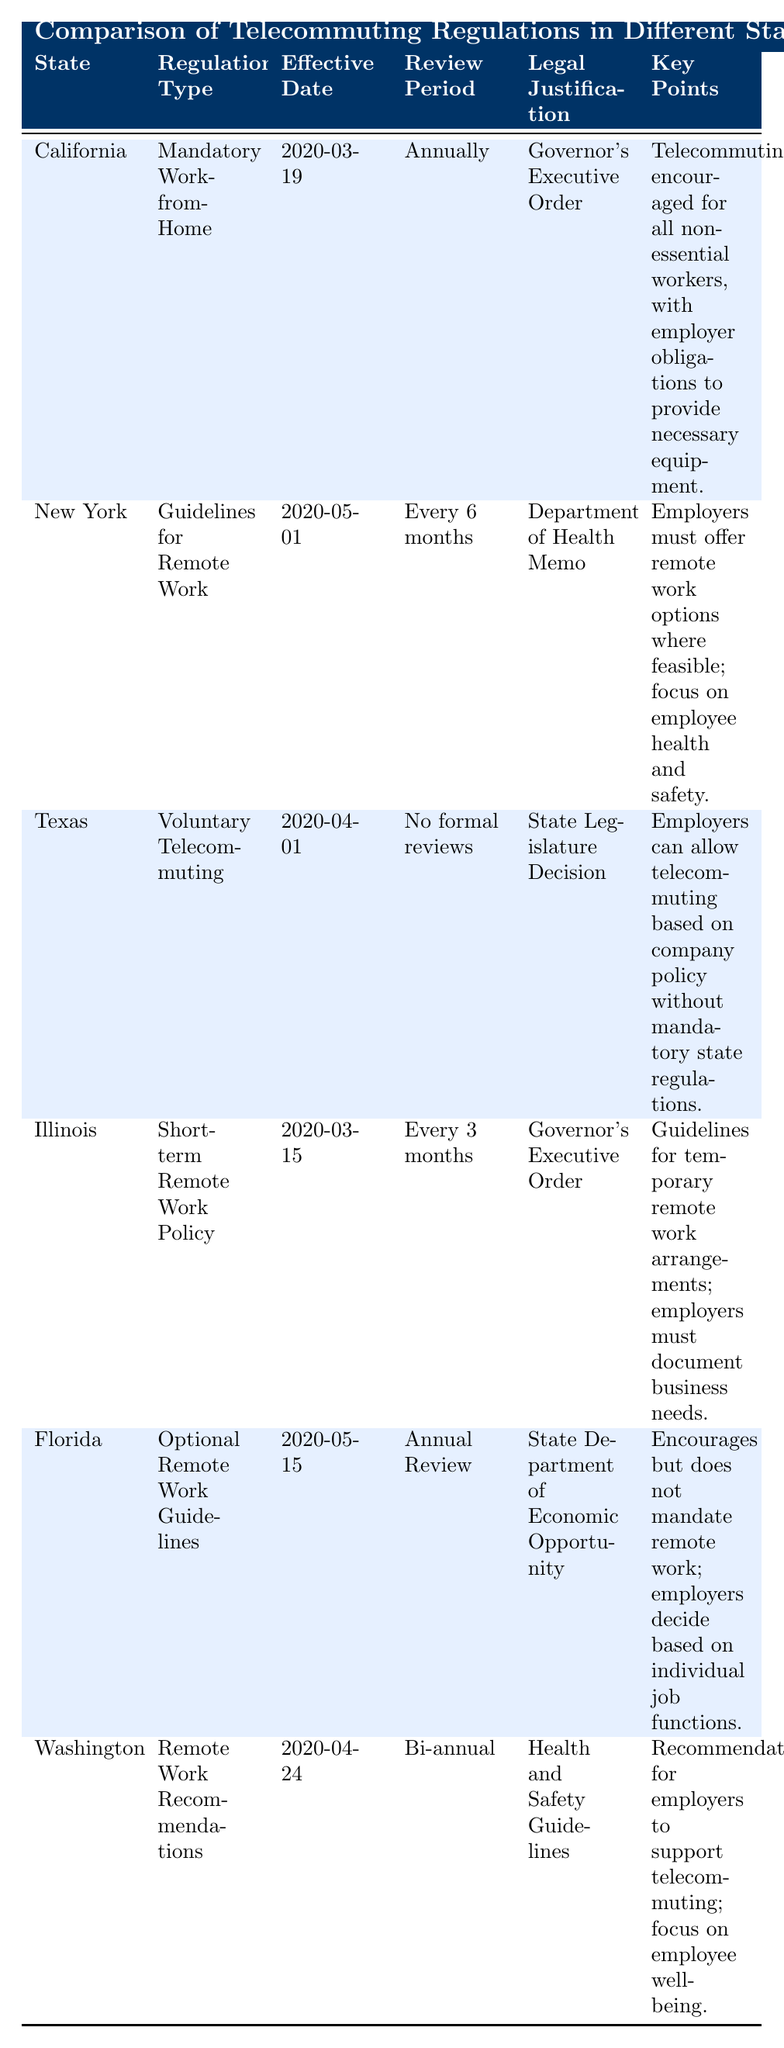What is the regulation type for California? The table lists California under the "Regulation Type" column, where it states "Mandatory Work-from-Home."
Answer: Mandatory Work-from-Home Which state’s telecommuting regulation was effective on May 1, 2020? The "Effective Date" column shows that New York has the effective date of May 1, 2020.
Answer: New York How often does Illinois review its short-term remote work policy? From the "Review Period" column, Illinois has a review period set to "Every 3 months."
Answer: Every 3 months Do Texas regulations mandate employers to allow telecommuting? The rows show that Texas has a "Voluntary Telecommuting" regulation, indicating that it does not mandate telecommuting but allows employers to choose.
Answer: No What is the legal justification for Florida's telecommuting guidelines? The "Legal Justification" column specifies that Florida's guidelines are issued by the "State Department of Economic Opportunity."
Answer: State Department of Economic Opportunity Which two states have guidelines that require employers to offer remote work options? By examining the "Key Points" column, both California and New York have specific guidelines that require employers to provide remote work options to their employees.
Answer: California and New York What is the average review period for the states listed in the table? The review periods are: Annually (California), Every 6 months (New York), No formal reviews (Texas), Every 3 months (Illinois), Annual Review (Florida), and Bi-annual (Washington). Converting these to months gives us 12, 6, 0, 3, 12, and 6. The average is (12 + 6 + 0 + 3 + 12 + 6) / 6 = 39 / 6 = 6.5 months.
Answer: 6.5 months Which state offers the most frequent review period for telecommuting regulations? Comparing the "Review Period" column, Illinois has the most frequent review period by reviewing every 3 months, more frequently than any other state listed.
Answer: Illinois Is the focus of Washington's remote work regulations more on recommendations or mandates? The "Key Points" column for Washington states that it offers "Remote Work Recommendations," indicating that these are not mandates but suggestions.
Answer: Recommendations What do the key points for New York emphasize regarding telecommuting? The "Key Points" entry for New York specifies the need for employers to offer remote work options where feasible, with a focus on employee health and safety.
Answer: Employee health and safety 